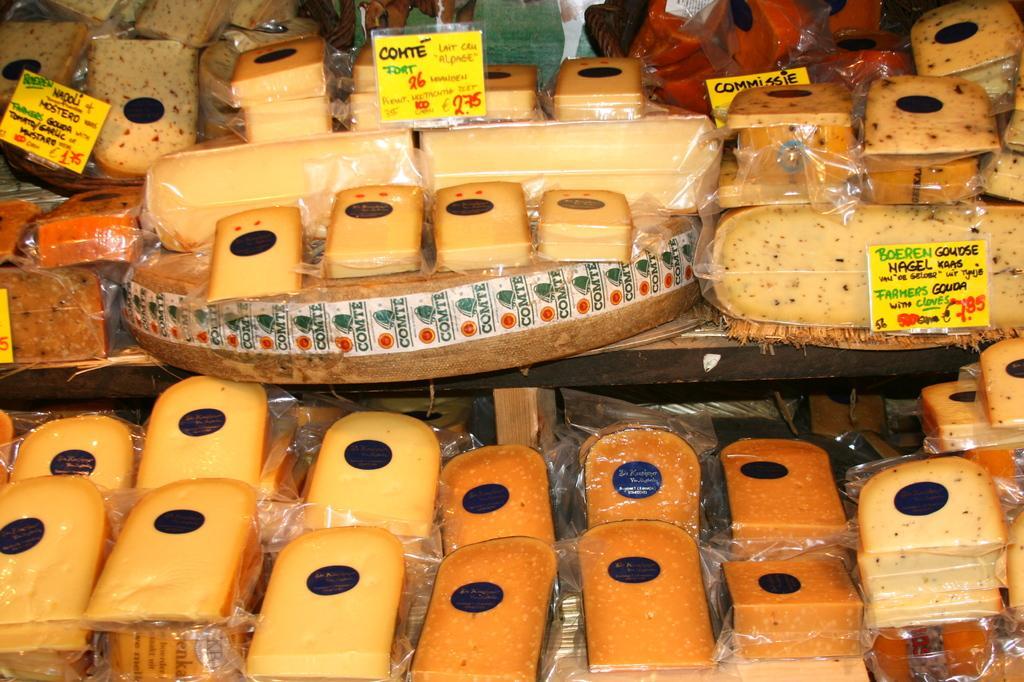In one or two sentences, can you explain what this image depicts? In this image I can see few food items, they are in brown color and I can also see few boards in yellow color and something written on it. 